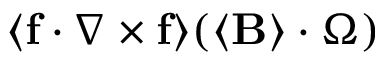<formula> <loc_0><loc_0><loc_500><loc_500>\langle f \cdot \nabla \times f \rangle ( \langle B \rangle \cdot \Omega )</formula> 